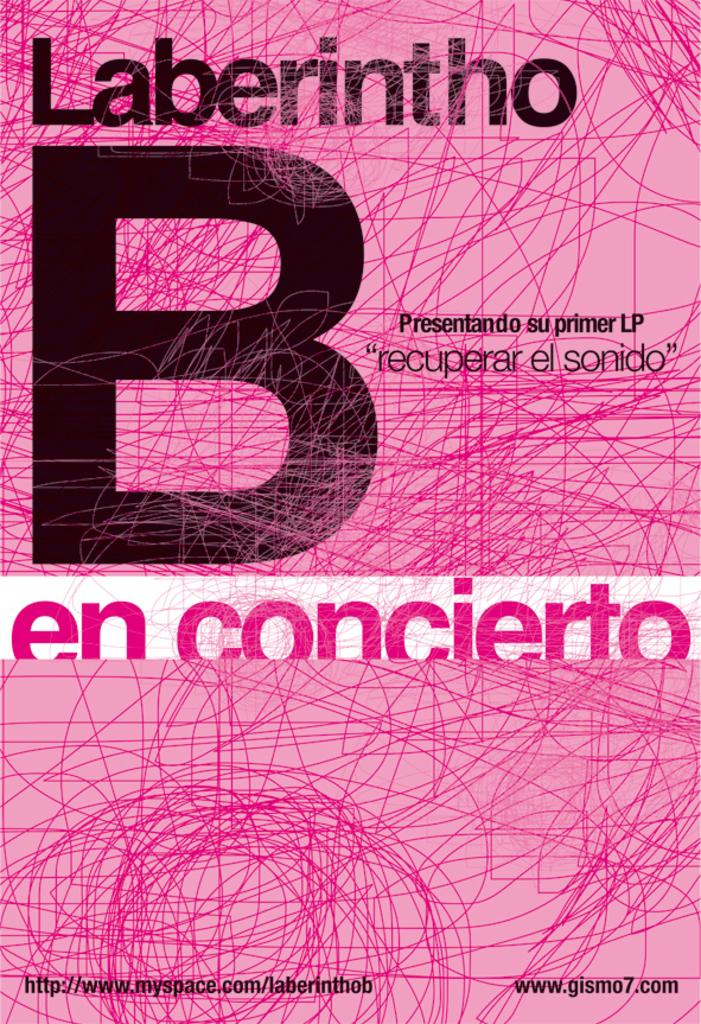Provide a one-sentence caption for the provided image. A book cover in Pepto Bismol pink with a huge B on it. 